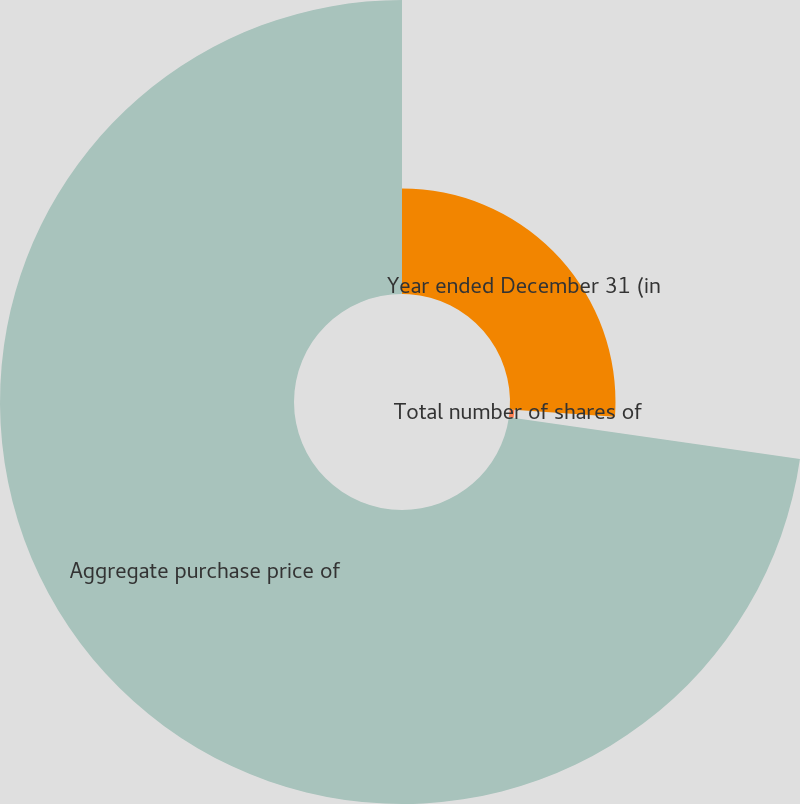Convert chart. <chart><loc_0><loc_0><loc_500><loc_500><pie_chart><fcel>Year ended December 31 (in<fcel>Total number of shares of<fcel>Aggregate purchase price of<nl><fcel>26.1%<fcel>1.16%<fcel>72.74%<nl></chart> 